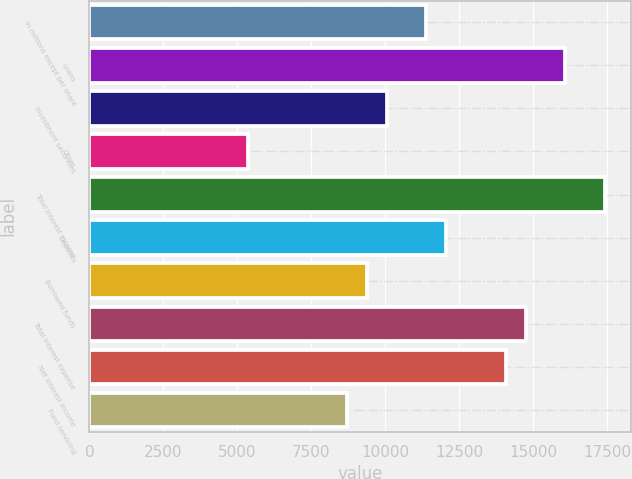Convert chart. <chart><loc_0><loc_0><loc_500><loc_500><bar_chart><fcel>In millions except per share<fcel>Loans<fcel>Investment securities<fcel>Other<fcel>Total interest income<fcel>Deposits<fcel>Borrowed funds<fcel>Total interest expense<fcel>Net interest income<fcel>Fund servicing<nl><fcel>11395.5<fcel>16086<fcel>10055.3<fcel>5364.88<fcel>17426.1<fcel>12065.5<fcel>9385.27<fcel>14745.8<fcel>14075.8<fcel>8715.2<nl></chart> 